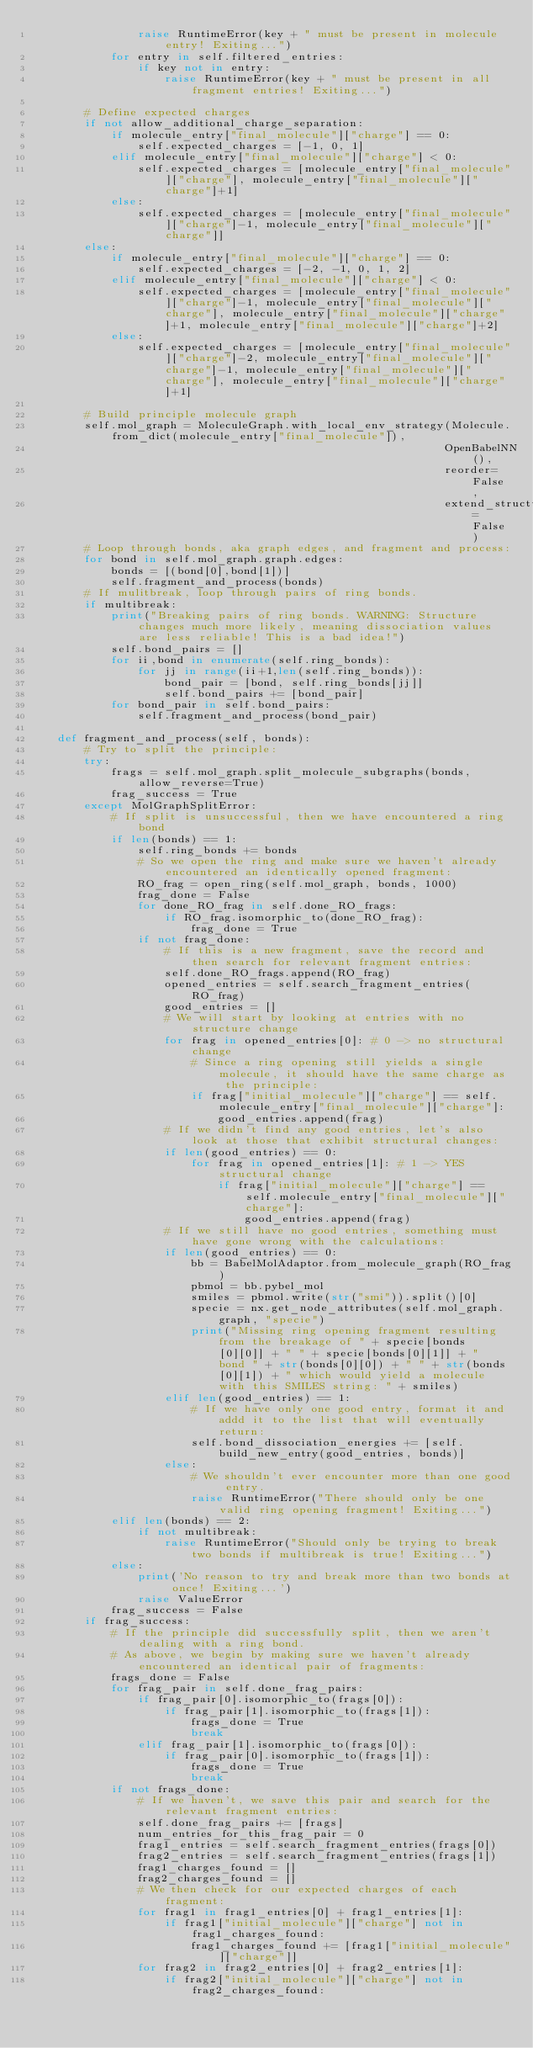Convert code to text. <code><loc_0><loc_0><loc_500><loc_500><_Python_>                raise RuntimeError(key + " must be present in molecule entry! Exiting...")
            for entry in self.filtered_entries:
                if key not in entry:
                    raise RuntimeError(key + " must be present in all fragment entries! Exiting...")

        # Define expected charges
        if not allow_additional_charge_separation:
            if molecule_entry["final_molecule"]["charge"] == 0:
                self.expected_charges = [-1, 0, 1]
            elif molecule_entry["final_molecule"]["charge"] < 0:
                self.expected_charges = [molecule_entry["final_molecule"]["charge"], molecule_entry["final_molecule"]["charge"]+1]
            else:
                self.expected_charges = [molecule_entry["final_molecule"]["charge"]-1, molecule_entry["final_molecule"]["charge"]]
        else:
            if molecule_entry["final_molecule"]["charge"] == 0:
                self.expected_charges = [-2, -1, 0, 1, 2]
            elif molecule_entry["final_molecule"]["charge"] < 0:
                self.expected_charges = [molecule_entry["final_molecule"]["charge"]-1, molecule_entry["final_molecule"]["charge"], molecule_entry["final_molecule"]["charge"]+1, molecule_entry["final_molecule"]["charge"]+2]
            else:
                self.expected_charges = [molecule_entry["final_molecule"]["charge"]-2, molecule_entry["final_molecule"]["charge"]-1, molecule_entry["final_molecule"]["charge"], molecule_entry["final_molecule"]["charge"]+1]

        # Build principle molecule graph
        self.mol_graph = MoleculeGraph.with_local_env_strategy(Molecule.from_dict(molecule_entry["final_molecule"]),
                                                              OpenBabelNN(),
                                                              reorder=False,
                                                              extend_structure=False)
        # Loop through bonds, aka graph edges, and fragment and process:
        for bond in self.mol_graph.graph.edges:
            bonds = [(bond[0],bond[1])]
            self.fragment_and_process(bonds)
        # If mulitbreak, loop through pairs of ring bonds.
        if multibreak:
            print("Breaking pairs of ring bonds. WARNING: Structure changes much more likely, meaning dissociation values are less reliable! This is a bad idea!")
            self.bond_pairs = []
            for ii,bond in enumerate(self.ring_bonds):
                for jj in range(ii+1,len(self.ring_bonds)):
                    bond_pair = [bond, self.ring_bonds[jj]]
                    self.bond_pairs += [bond_pair]
            for bond_pair in self.bond_pairs:
                self.fragment_and_process(bond_pair)

    def fragment_and_process(self, bonds):
        # Try to split the principle:
        try:
            frags = self.mol_graph.split_molecule_subgraphs(bonds,allow_reverse=True)
            frag_success = True
        except MolGraphSplitError:
            # If split is unsuccessful, then we have encountered a ring bond
            if len(bonds) == 1:
                self.ring_bonds += bonds
                # So we open the ring and make sure we haven't already encountered an identically opened fragment:
                RO_frag = open_ring(self.mol_graph, bonds, 1000)
                frag_done = False
                for done_RO_frag in self.done_RO_frags:
                    if RO_frag.isomorphic_to(done_RO_frag):
                        frag_done = True
                if not frag_done:
                    # If this is a new fragment, save the record and then search for relevant fragment entries:
                    self.done_RO_frags.append(RO_frag)
                    opened_entries = self.search_fragment_entries(RO_frag)
                    good_entries = []
                    # We will start by looking at entries with no structure change
                    for frag in opened_entries[0]: # 0 -> no structural change
                        # Since a ring opening still yields a single molecule, it should have the same charge as the principle:
                        if frag["initial_molecule"]["charge"] == self.molecule_entry["final_molecule"]["charge"]:
                            good_entries.append(frag)
                    # If we didn't find any good entries, let's also look at those that exhibit structural changes:
                    if len(good_entries) == 0:
                        for frag in opened_entries[1]: # 1 -> YES structural change
                            if frag["initial_molecule"]["charge"] == self.molecule_entry["final_molecule"]["charge"]:
                                good_entries.append(frag)
                    # If we still have no good entries, something must have gone wrong with the calculations:
                    if len(good_entries) == 0:
                        bb = BabelMolAdaptor.from_molecule_graph(RO_frag)
                        pbmol = bb.pybel_mol
                        smiles = pbmol.write(str("smi")).split()[0]
                        specie = nx.get_node_attributes(self.mol_graph.graph, "specie")
                        print("Missing ring opening fragment resulting from the breakage of " + specie[bonds[0][0]] + " " + specie[bonds[0][1]] + " bond " + str(bonds[0][0]) + " " + str(bonds[0][1]) + " which would yield a molecule with this SMILES string: " + smiles)
                    elif len(good_entries) == 1:
                        # If we have only one good entry, format it and addd it to the list that will eventually return:
                        self.bond_dissociation_energies += [self.build_new_entry(good_entries, bonds)]
                    else:
                        # We shouldn't ever encounter more than one good entry.
                        raise RuntimeError("There should only be one valid ring opening fragment! Exiting...")
            elif len(bonds) == 2:
                if not multibreak:
                    raise RuntimeError("Should only be trying to break two bonds if multibreak is true! Exiting...")
            else:
                print('No reason to try and break more than two bonds at once! Exiting...')
                raise ValueError
            frag_success = False
        if frag_success:
            # If the principle did successfully split, then we aren't dealing with a ring bond.
            # As above, we begin by making sure we haven't already encountered an identical pair of fragments:
            frags_done = False
            for frag_pair in self.done_frag_pairs:
                if frag_pair[0].isomorphic_to(frags[0]):
                    if frag_pair[1].isomorphic_to(frags[1]):
                        frags_done = True
                        break
                elif frag_pair[1].isomorphic_to(frags[0]):
                    if frag_pair[0].isomorphic_to(frags[1]):
                        frags_done = True
                        break
            if not frags_done:
                # If we haven't, we save this pair and search for the relevant fragment entries:
                self.done_frag_pairs += [frags]
                num_entries_for_this_frag_pair = 0
                frag1_entries = self.search_fragment_entries(frags[0])
                frag2_entries = self.search_fragment_entries(frags[1])
                frag1_charges_found = []
                frag2_charges_found = []
                # We then check for our expected charges of each fragment:
                for frag1 in frag1_entries[0] + frag1_entries[1]:
                    if frag1["initial_molecule"]["charge"] not in frag1_charges_found:
                        frag1_charges_found += [frag1["initial_molecule"]["charge"]]
                for frag2 in frag2_entries[0] + frag2_entries[1]:
                    if frag2["initial_molecule"]["charge"] not in frag2_charges_found:</code> 